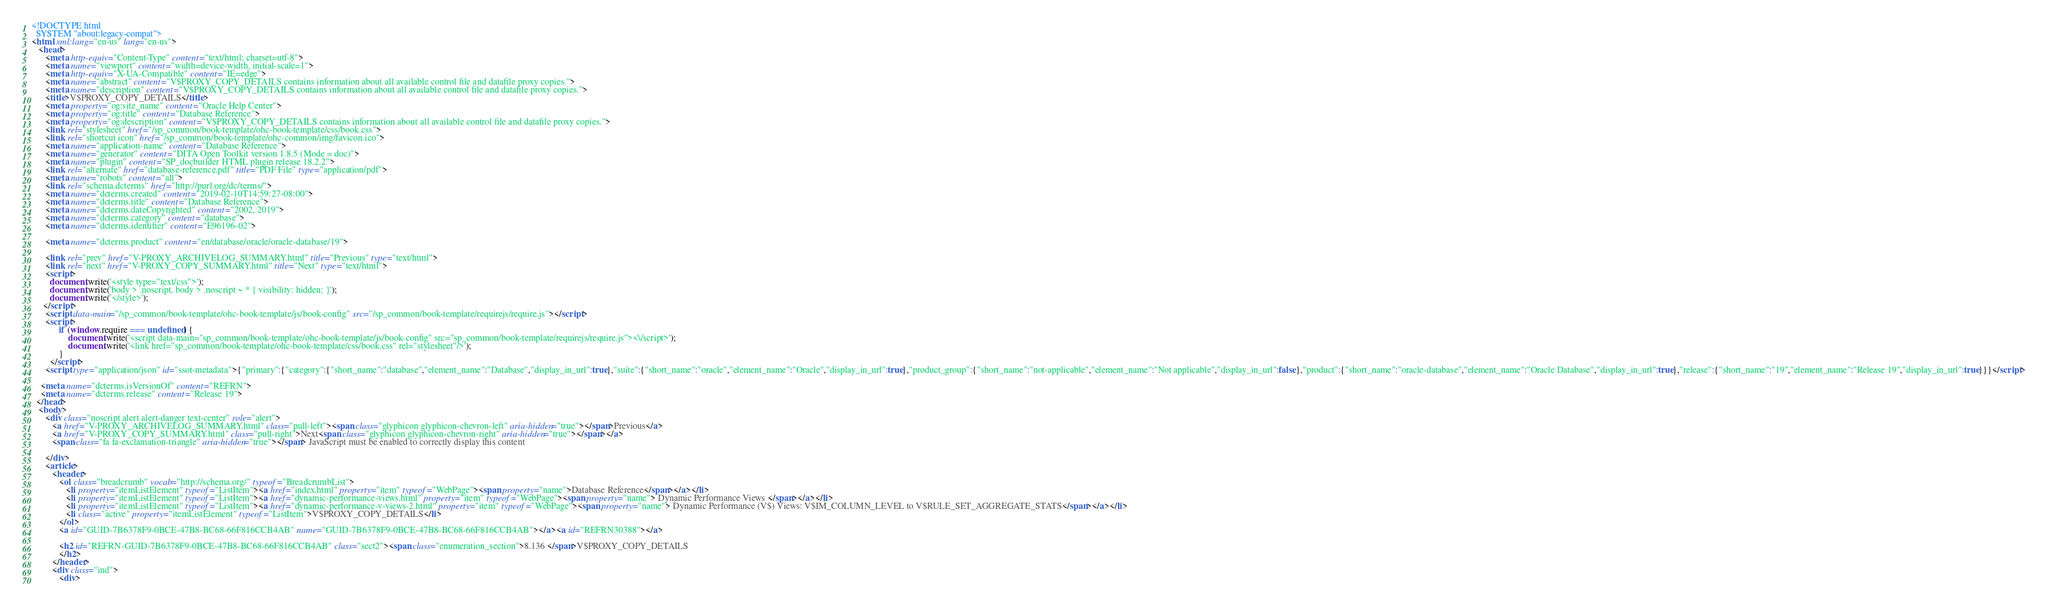<code> <loc_0><loc_0><loc_500><loc_500><_HTML_><!DOCTYPE html
  SYSTEM "about:legacy-compat">
<html xml:lang="en-us" lang="en-us">
   <head>
      <meta http-equiv="Content-Type" content="text/html; charset=utf-8">
      <meta name="viewport" content="width=device-width, initial-scale=1">
      <meta http-equiv="X-UA-Compatible" content="IE=edge">
      <meta name="abstract" content="V$PROXY_COPY_DETAILS contains information about all available control file and datafile proxy copies.">
      <meta name="description" content="V$PROXY_COPY_DETAILS contains information about all available control file and datafile proxy copies.">
      <title>V$PROXY_COPY_DETAILS</title>
      <meta property="og:site_name" content="Oracle Help Center">
      <meta property="og:title" content="Database Reference">
      <meta property="og:description" content="V$PROXY_COPY_DETAILS contains information about all available control file and datafile proxy copies.">
      <link rel="stylesheet" href="/sp_common/book-template/ohc-book-template/css/book.css">
      <link rel="shortcut icon" href="/sp_common/book-template/ohc-common/img/favicon.ico">
      <meta name="application-name" content="Database Reference">
      <meta name="generator" content="DITA Open Toolkit version 1.8.5 (Mode = doc)">
      <meta name="plugin" content="SP_docbuilder HTML plugin release 18.2.2">
      <link rel="alternate" href="database-reference.pdf" title="PDF File" type="application/pdf">
      <meta name="robots" content="all">
      <link rel="schema.dcterms" href="http://purl.org/dc/terms/">
      <meta name="dcterms.created" content="2019-02-10T14:59:27-08:00">
      <meta name="dcterms.title" content="Database Reference">
      <meta name="dcterms.dateCopyrighted" content="2002, 2019">
      <meta name="dcterms.category" content="database">
      <meta name="dcterms.identifier" content="E96196-02">
      
      <meta name="dcterms.product" content="en/database/oracle/oracle-database/19">
      
      <link rel="prev" href="V-PROXY_ARCHIVELOG_SUMMARY.html" title="Previous" type="text/html">
      <link rel="next" href="V-PROXY_COPY_SUMMARY.html" title="Next" type="text/html">
      <script>
        document.write('<style type="text/css">');
        document.write('body > .noscript, body > .noscript ~ * { visibility: hidden; }');
        document.write('</style>');
     </script>
      <script data-main="/sp_common/book-template/ohc-book-template/js/book-config" src="/sp_common/book-template/requirejs/require.js"></script>
      <script>
            if (window.require === undefined) {
                document.write('<script data-main="sp_common/book-template/ohc-book-template/js/book-config" src="sp_common/book-template/requirejs/require.js"><\/script>');
                document.write('<link href="sp_common/book-template/ohc-book-template/css/book.css" rel="stylesheet"/>');
            }
        </script>
      <script type="application/json" id="ssot-metadata">{"primary":{"category":{"short_name":"database","element_name":"Database","display_in_url":true},"suite":{"short_name":"oracle","element_name":"Oracle","display_in_url":true},"product_group":{"short_name":"not-applicable","element_name":"Not applicable","display_in_url":false},"product":{"short_name":"oracle-database","element_name":"Oracle Database","display_in_url":true},"release":{"short_name":"19","element_name":"Release 19","display_in_url":true}}}</script>
      
    <meta name="dcterms.isVersionOf" content="REFRN">
    <meta name="dcterms.release" content="Release 19">
  </head>
   <body>
      <div class="noscript alert alert-danger text-center" role="alert">
         <a href="V-PROXY_ARCHIVELOG_SUMMARY.html" class="pull-left"><span class="glyphicon glyphicon-chevron-left" aria-hidden="true"></span>Previous</a>
         <a href="V-PROXY_COPY_SUMMARY.html" class="pull-right">Next<span class="glyphicon glyphicon-chevron-right" aria-hidden="true"></span></a>
         <span class="fa fa-exclamation-triangle" aria-hidden="true"></span> JavaScript must be enabled to correctly display this content
        
      </div>
      <article>
         <header>
            <ol class="breadcrumb" vocab="http://schema.org/" typeof="BreadcrumbList">
               <li property="itemListElement" typeof="ListItem"><a href="index.html" property="item" typeof="WebPage"><span property="name">Database Reference</span></a></li>
               <li property="itemListElement" typeof="ListItem"><a href="dynamic-performance-views.html" property="item" typeof="WebPage"><span property="name"> Dynamic Performance Views </span></a></li>
               <li property="itemListElement" typeof="ListItem"><a href="dynamic-performance-v-views-2.html" property="item" typeof="WebPage"><span property="name"> Dynamic Performance (V$) Views: V$IM_COLUMN_LEVEL to V$RULE_SET_AGGREGATE_STATS</span></a></li>
               <li class="active" property="itemListElement" typeof="ListItem">V$PROXY_COPY_DETAILS</li>
            </ol>
            <a id="GUID-7B6378F9-0BCE-47B8-BC68-66F816CCB4AB" name="GUID-7B6378F9-0BCE-47B8-BC68-66F816CCB4AB"></a><a id="REFRN30388"></a>
            
            <h2 id="REFRN-GUID-7B6378F9-0BCE-47B8-BC68-66F816CCB4AB" class="sect2"><span class="enumeration_section">8.136 </span>V$PROXY_COPY_DETAILS
            </h2>
         </header>
         <div class="ind">
            <div></code> 